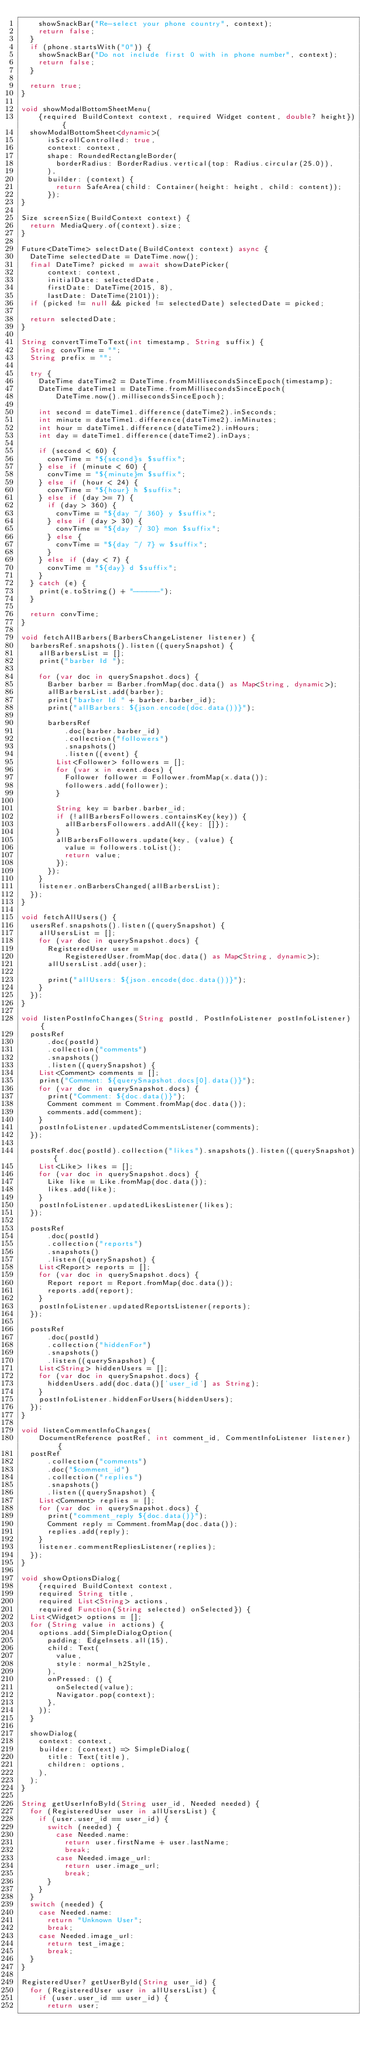<code> <loc_0><loc_0><loc_500><loc_500><_Dart_>    showSnackBar("Re-select your phone country", context);
    return false;
  }
  if (phone.startsWith("0")) {
    showSnackBar("Do not include first 0 with in phone number", context);
    return false;
  }

  return true;
}

void showModalBottomSheetMenu(
    {required BuildContext context, required Widget content, double? height}) {
  showModalBottomSheet<dynamic>(
      isScrollControlled: true,
      context: context,
      shape: RoundedRectangleBorder(
        borderRadius: BorderRadius.vertical(top: Radius.circular(25.0)),
      ),
      builder: (context) {
        return SafeArea(child: Container(height: height, child: content));
      });
}

Size screenSize(BuildContext context) {
  return MediaQuery.of(context).size;
}

Future<DateTime> selectDate(BuildContext context) async {
  DateTime selectedDate = DateTime.now();
  final DateTime? picked = await showDatePicker(
      context: context,
      initialDate: selectedDate,
      firstDate: DateTime(2015, 8),
      lastDate: DateTime(2101));
  if (picked != null && picked != selectedDate) selectedDate = picked;

  return selectedDate;
}

String convertTimeToText(int timestamp, String suffix) {
  String convTime = "";
  String prefix = "";

  try {
    DateTime dateTime2 = DateTime.fromMillisecondsSinceEpoch(timestamp);
    DateTime dateTime1 = DateTime.fromMillisecondsSinceEpoch(
        DateTime.now().millisecondsSinceEpoch);

    int second = dateTime1.difference(dateTime2).inSeconds;
    int minute = dateTime1.difference(dateTime2).inMinutes;
    int hour = dateTime1.difference(dateTime2).inHours;
    int day = dateTime1.difference(dateTime2).inDays;

    if (second < 60) {
      convTime = "${second}s $suffix";
    } else if (minute < 60) {
      convTime = "${minute}m $suffix";
    } else if (hour < 24) {
      convTime = "${hour} h $suffix";
    } else if (day >= 7) {
      if (day > 360) {
        convTime = "${day ~/ 360} y $suffix";
      } else if (day > 30) {
        convTime = "${day ~/ 30} mon $suffix";
      } else {
        convTime = "${day ~/ 7} w $suffix";
      }
    } else if (day < 7) {
      convTime = "${day} d $suffix";
    }
  } catch (e) {
    print(e.toString() + "------");
  }

  return convTime;
}

void fetchAllBarbers(BarbersChangeListener listener) {
  barbersRef.snapshots().listen((querySnapshot) {
    allBarbersList = [];
    print("barber Id ");

    for (var doc in querySnapshot.docs) {
      Barber barber = Barber.fromMap(doc.data() as Map<String, dynamic>);
      allBarbersList.add(barber);
      print("barber Id " + barber.barber_id);
      print("allBarbers: ${json.encode(doc.data())}");

      barbersRef
          .doc(barber.barber_id)
          .collection("followers")
          .snapshots()
          .listen((event) {
        List<Follower> followers = [];
        for (var x in event.docs) {
          Follower follower = Follower.fromMap(x.data());
          followers.add(follower);
        }

        String key = barber.barber_id;
        if (!allBarbersFollowers.containsKey(key)) {
          allBarbersFollowers.addAll({key: []});
        }
        allBarbersFollowers.update(key, (value) {
          value = followers.toList();
          return value;
        });
      });
    }
    listener.onBarbersChanged(allBarbersList);
  });
}

void fetchAllUsers() {
  usersRef.snapshots().listen((querySnapshot) {
    allUsersList = [];
    for (var doc in querySnapshot.docs) {
      RegisteredUser user =
          RegisteredUser.fromMap(doc.data() as Map<String, dynamic>);
      allUsersList.add(user);

      print("allUsers: ${json.encode(doc.data())}");
    }
  });
}

void listenPostInfoChanges(String postId, PostInfoListener postInfoListener) {
  postsRef
      .doc(postId)
      .collection("comments")
      .snapshots()
      .listen((querySnapshot) {
    List<Comment> comments = [];
    print("Comment: ${querySnapshot.docs[0].data()}");
    for (var doc in querySnapshot.docs) {
      print("Comment: ${doc.data()}");
      Comment comment = Comment.fromMap(doc.data());
      comments.add(comment);
    }
    postInfoListener.updatedCommentsListener(comments);
  });

  postsRef.doc(postId).collection("likes").snapshots().listen((querySnapshot) {
    List<Like> likes = [];
    for (var doc in querySnapshot.docs) {
      Like like = Like.fromMap(doc.data());
      likes.add(like);
    }
    postInfoListener.updatedLikesListener(likes);
  });

  postsRef
      .doc(postId)
      .collection("reports")
      .snapshots()
      .listen((querySnapshot) {
    List<Report> reports = [];
    for (var doc in querySnapshot.docs) {
      Report report = Report.fromMap(doc.data());
      reports.add(report);
    }
    postInfoListener.updatedReportsListener(reports);
  });

  postsRef
      .doc(postId)
      .collection("hiddenFor")
      .snapshots()
      .listen((querySnapshot) {
    List<String> hiddenUsers = [];
    for (var doc in querySnapshot.docs) {
      hiddenUsers.add(doc.data()['user_id'] as String);
    }
    postInfoListener.hiddenForUsers(hiddenUsers);
  });
}

void listenCommentInfoChanges(
    DocumentReference postRef, int comment_id, CommentInfoListener listener) {
  postRef
      .collection("comments")
      .doc("$comment_id")
      .collection("replies")
      .snapshots()
      .listen((querySnapshot) {
    List<Comment> replies = [];
    for (var doc in querySnapshot.docs) {
      print("comment_reply ${doc.data()}");
      Comment reply = Comment.fromMap(doc.data());
      replies.add(reply);
    }
    listener.commentRepliesListener(replies);
  });
}

void showOptionsDialog(
    {required BuildContext context,
    required String title,
    required List<String> actions,
    required Function(String selected) onSelected}) {
  List<Widget> options = [];
  for (String value in actions) {
    options.add(SimpleDialogOption(
      padding: EdgeInsets.all(15),
      child: Text(
        value,
        style: normal_h2Style,
      ),
      onPressed: () {
        onSelected(value);
        Navigator.pop(context);
      },
    ));
  }

  showDialog(
    context: context,
    builder: (context) => SimpleDialog(
      title: Text(title),
      children: options,
    ),
  );
}

String getUserInfoById(String user_id, Needed needed) {
  for (RegisteredUser user in allUsersList) {
    if (user.user_id == user_id) {
      switch (needed) {
        case Needed.name:
          return user.firstName + user.lastName;
          break;
        case Needed.image_url:
          return user.image_url;
          break;
      }
    }
  }
  switch (needed) {
    case Needed.name:
      return "Unknown User";
      break;
    case Needed.image_url:
      return test_image;
      break;
  }
}

RegisteredUser? getUserById(String user_id) {
  for (RegisteredUser user in allUsersList) {
    if (user.user_id == user_id) {
      return user;</code> 